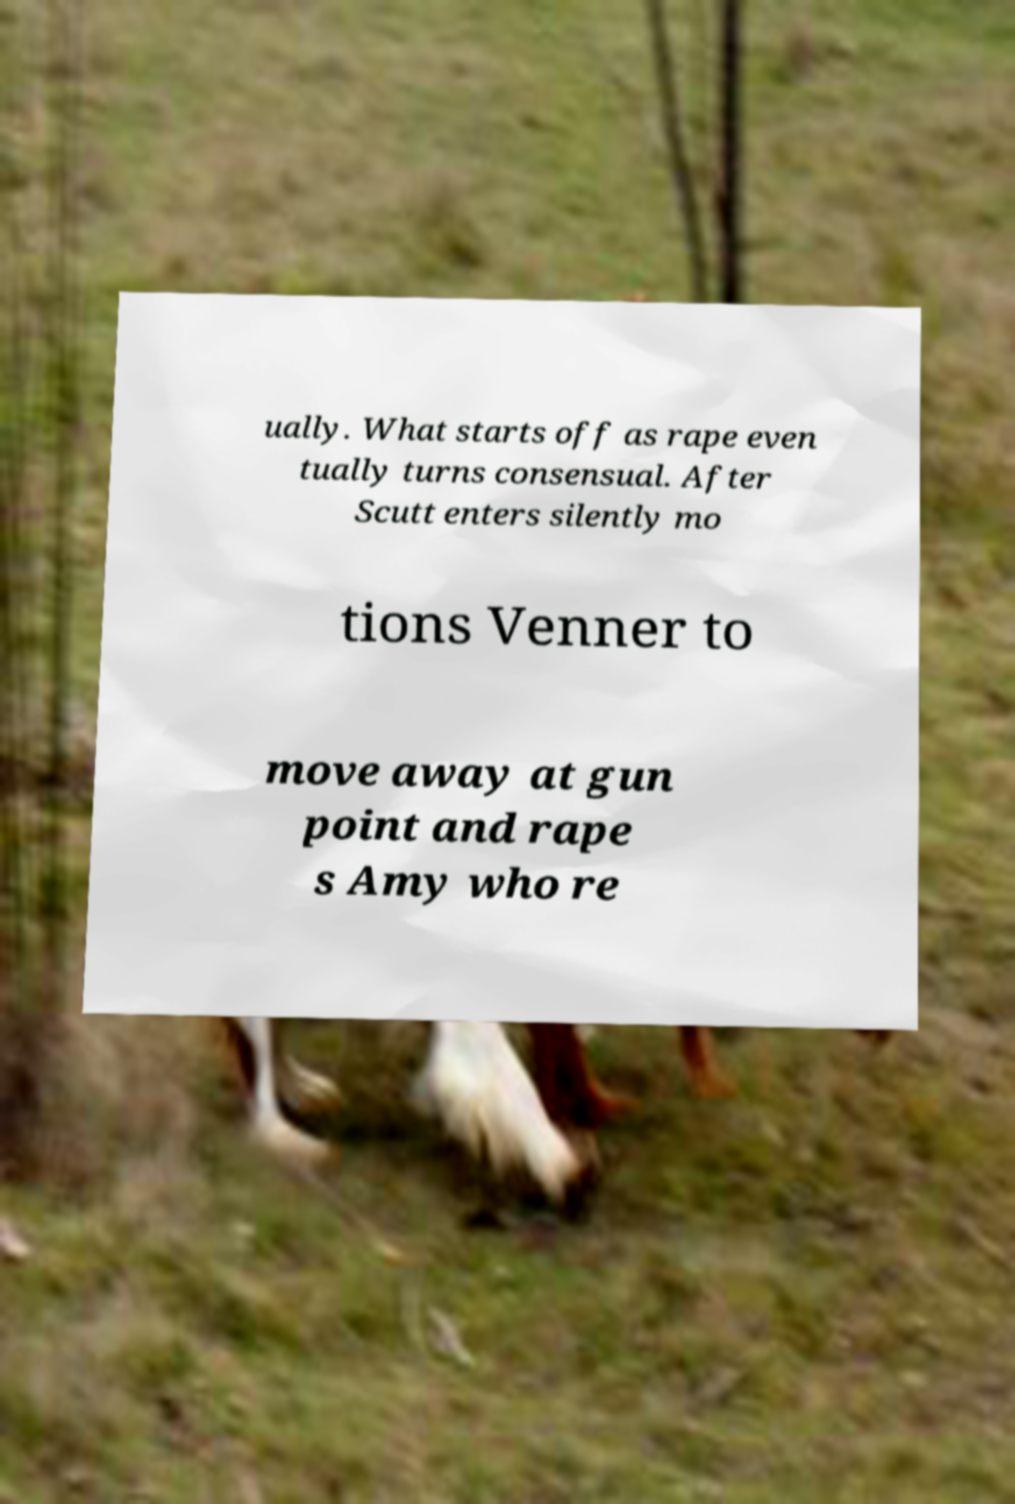I need the written content from this picture converted into text. Can you do that? ually. What starts off as rape even tually turns consensual. After Scutt enters silently mo tions Venner to move away at gun point and rape s Amy who re 